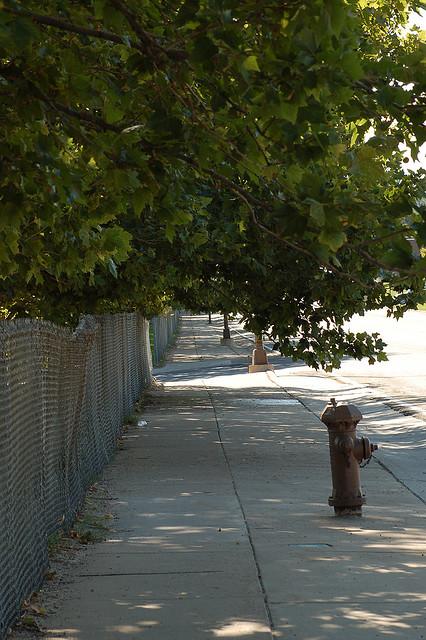Describe the weather conditions in the photo. The sky appears clear and the abundance of sunlight suggests that it's a fair-weather day, with no immediate signs of rain or overcast conditions. Do you think this area is well-maintained? The area appears moderately maintained; the trees are healthy and the sidewalk is intact, but there are some leaves on the ground which might indicate that street cleaning is not frequent. 